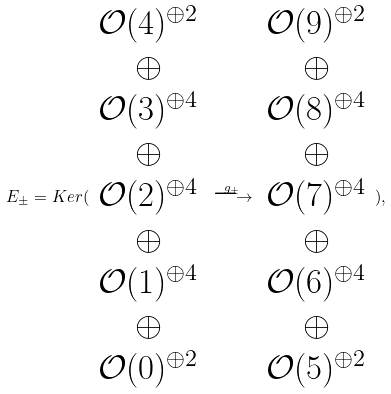Convert formula to latex. <formula><loc_0><loc_0><loc_500><loc_500>E _ { \pm } = K e r ( \begin{array} { c } \mathcal { O } ( 4 ) ^ { \oplus 2 } \\ \oplus \\ \mathcal { O } ( 3 ) ^ { \oplus 4 } \\ \oplus \\ \mathcal { O } ( 2 ) ^ { \oplus 4 } \\ \oplus \\ \mathcal { O } ( 1 ) ^ { \oplus 4 } \\ \oplus \\ \mathcal { O } ( 0 ) ^ { \oplus 2 } \end{array} \stackrel { g _ { \pm } } { \longrightarrow } \begin{array} { c } \mathcal { O } ( 9 ) ^ { \oplus 2 } \\ \oplus \\ \mathcal { O } ( 8 ) ^ { \oplus 4 } \\ \oplus \\ \mathcal { O } ( 7 ) ^ { \oplus 4 } \\ \oplus \\ \mathcal { O } ( 6 ) ^ { \oplus 4 } \\ \oplus \\ \mathcal { O } ( 5 ) ^ { \oplus 2 } \end{array} ) ,</formula> 